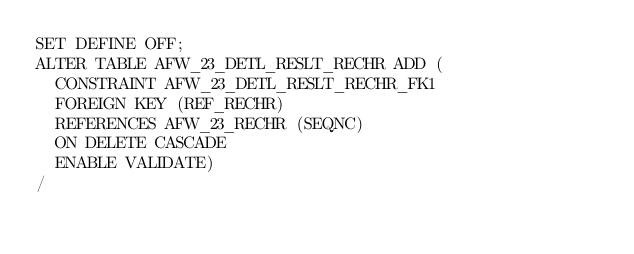<code> <loc_0><loc_0><loc_500><loc_500><_SQL_>SET DEFINE OFF;
ALTER TABLE AFW_23_DETL_RESLT_RECHR ADD (
  CONSTRAINT AFW_23_DETL_RESLT_RECHR_FK1 
  FOREIGN KEY (REF_RECHR) 
  REFERENCES AFW_23_RECHR (SEQNC)
  ON DELETE CASCADE
  ENABLE VALIDATE)
/
</code> 